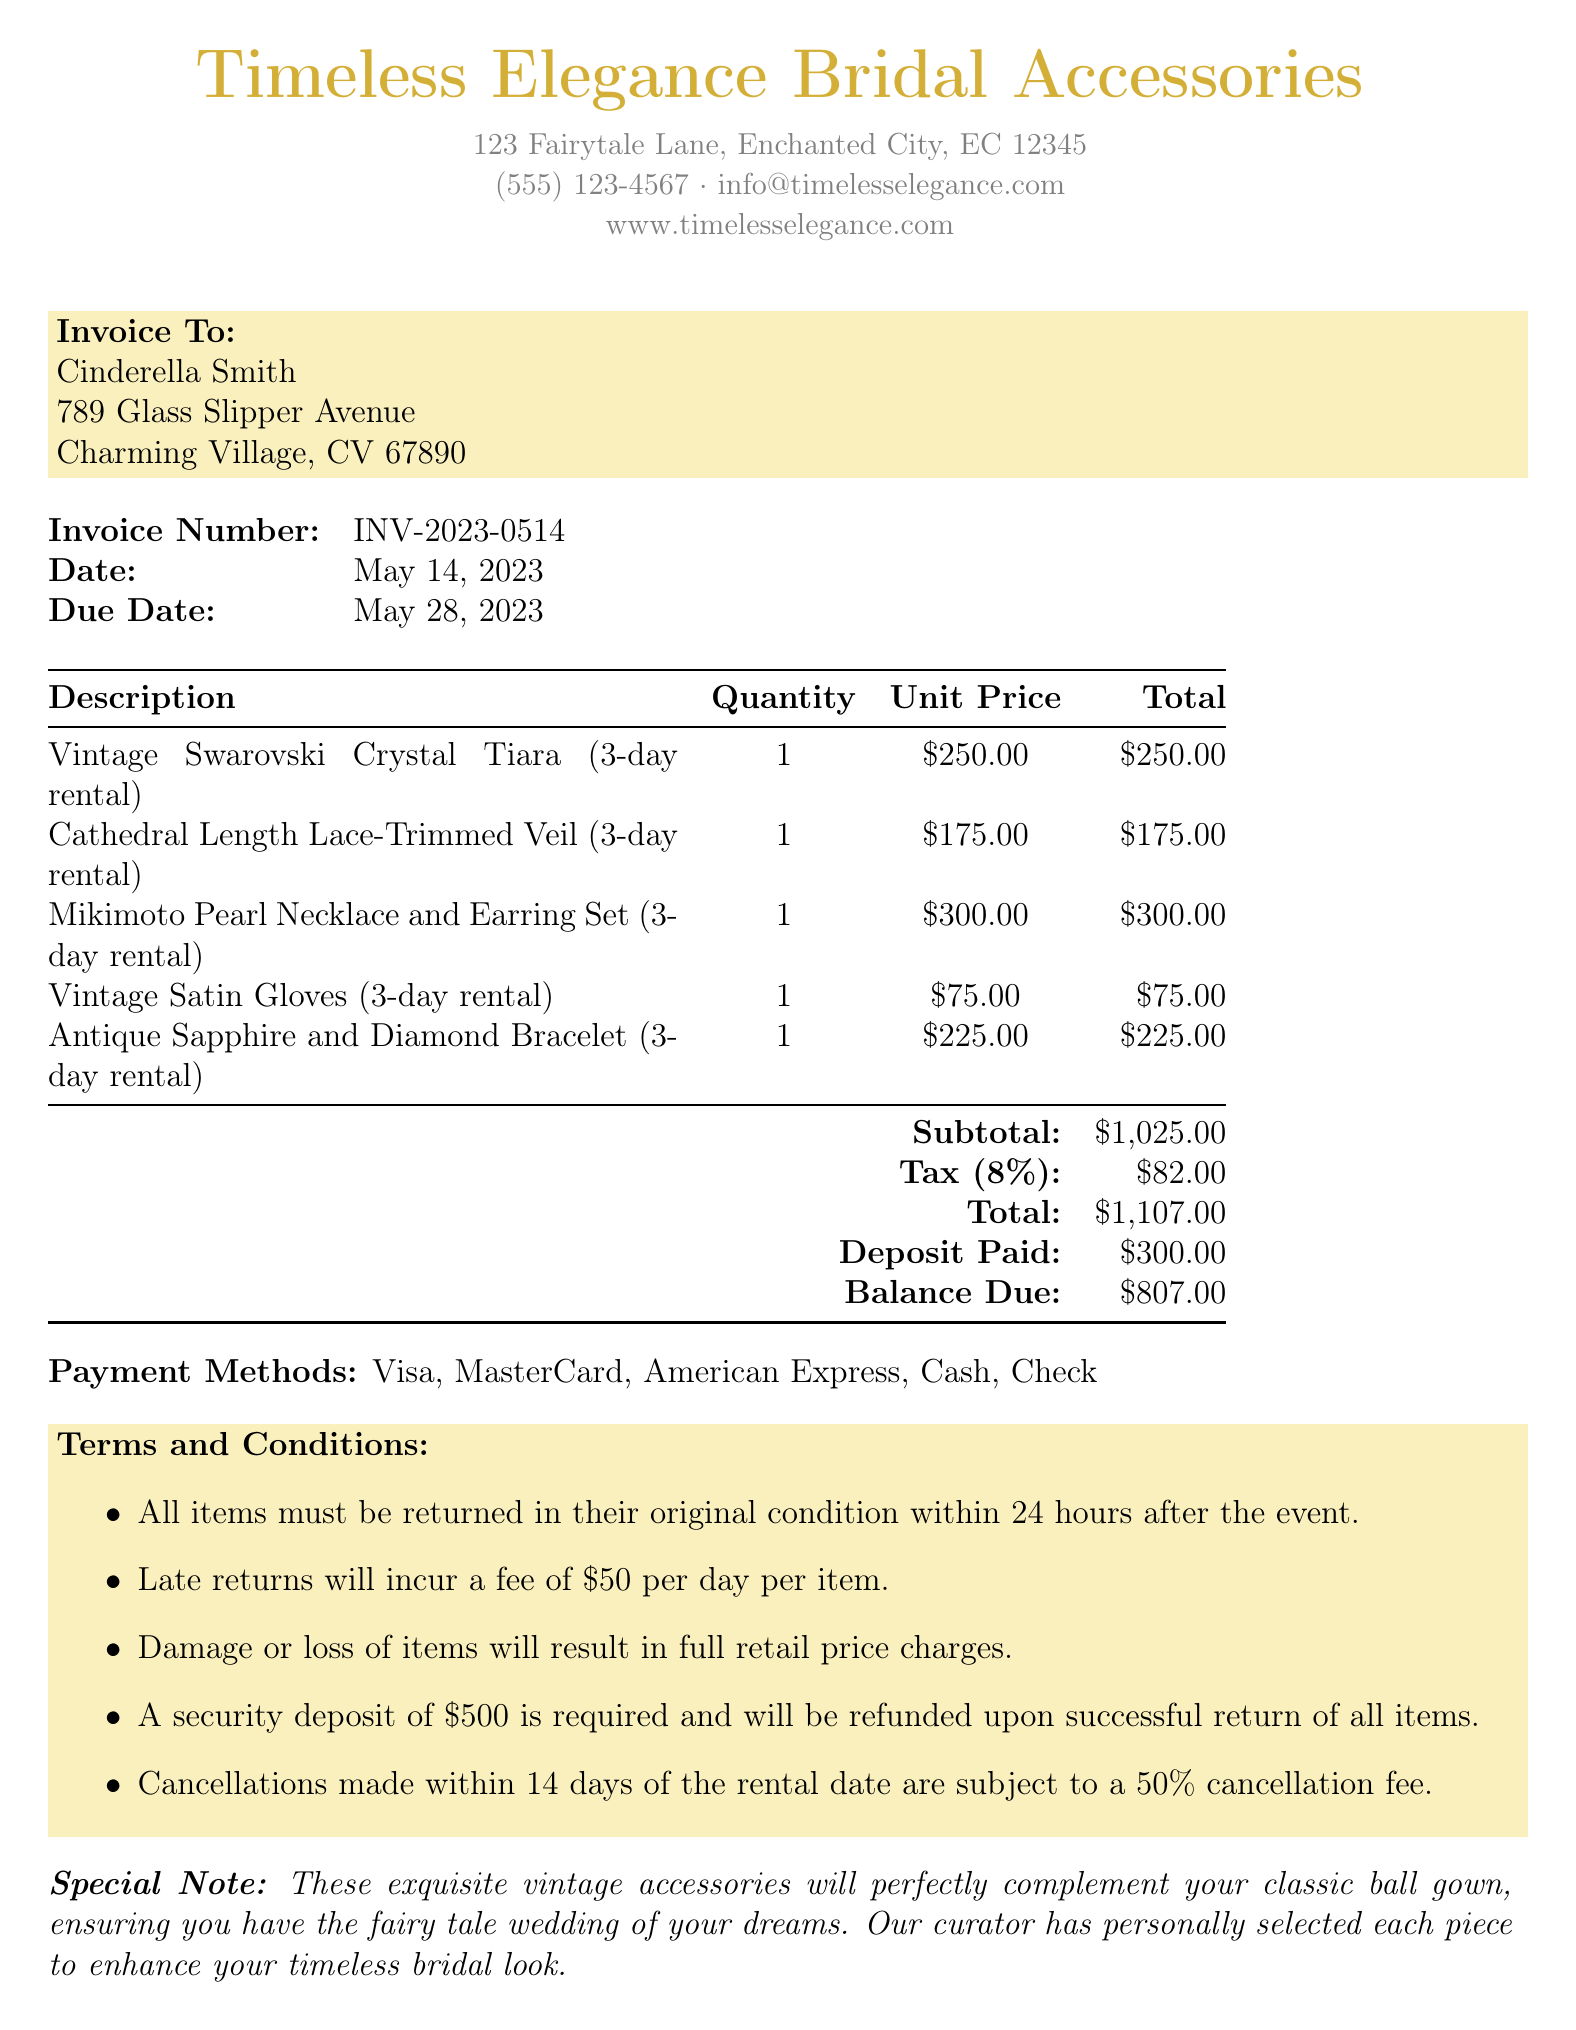What is the business name? The business name is located at the top of the document, representing the provider of the services.
Answer: Timeless Elegance Bridal Accessories What is the invoice number? The invoice number is specified in the table containing the essential details of the invoice.
Answer: INV-2023-0514 What is the total amount due? The total amount due is found at the bottom of the invoice, summarizing the total costs incurred.
Answer: $1107.00 Who is the client? The client's name is listed under the invoice details, indicating the recipient of the services.
Answer: Cinderella Smith What is the deposit paid amount? The deposit paid is included in the financial summary section of the invoice.
Answer: $300.00 What is the tax rate applied? The tax rate is specified in the breakdown of costs under the tax amount section.
Answer: 8% What items were rented for the wedding? The items rented are listed in the table with their descriptions, quantities, and totals.
Answer: Vintage Swarovski Crystal Tiara, Cathedral Length Lace-Trimmed Veil, Mikimoto Pearl Necklace and Earring Set, Vintage Satin Gloves, Antique Sapphire and Diamond Bracelet What is the balance due after the deposit? The balance due is calculated from the total and deposit paid, provided in the financial summary.
Answer: $807.00 What are the payment methods accepted? The payment methods section lists the options available for the client to settle the account.
Answer: Visa, MasterCard, American Express, Cash, Check 